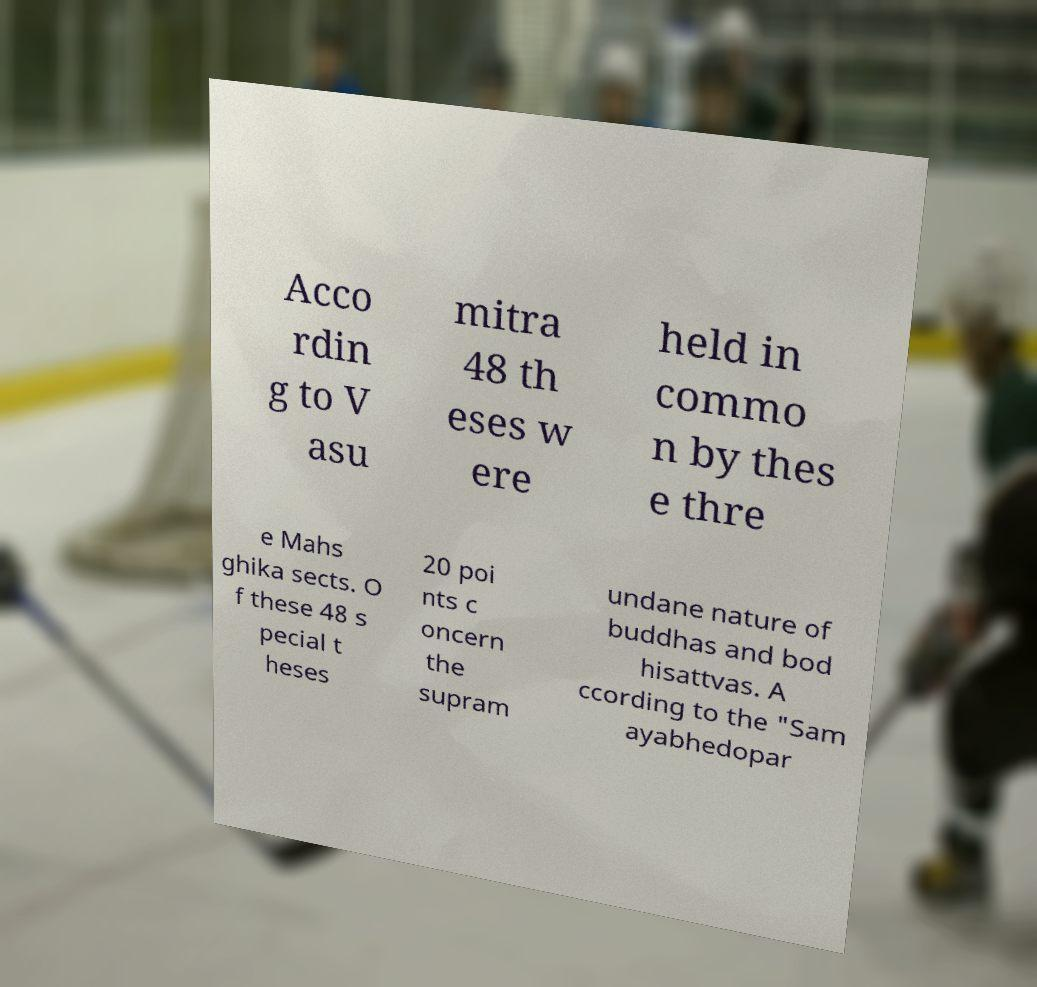What messages or text are displayed in this image? I need them in a readable, typed format. Acco rdin g to V asu mitra 48 th eses w ere held in commo n by thes e thre e Mahs ghika sects. O f these 48 s pecial t heses 20 poi nts c oncern the supram undane nature of buddhas and bod hisattvas. A ccording to the "Sam ayabhedopar 